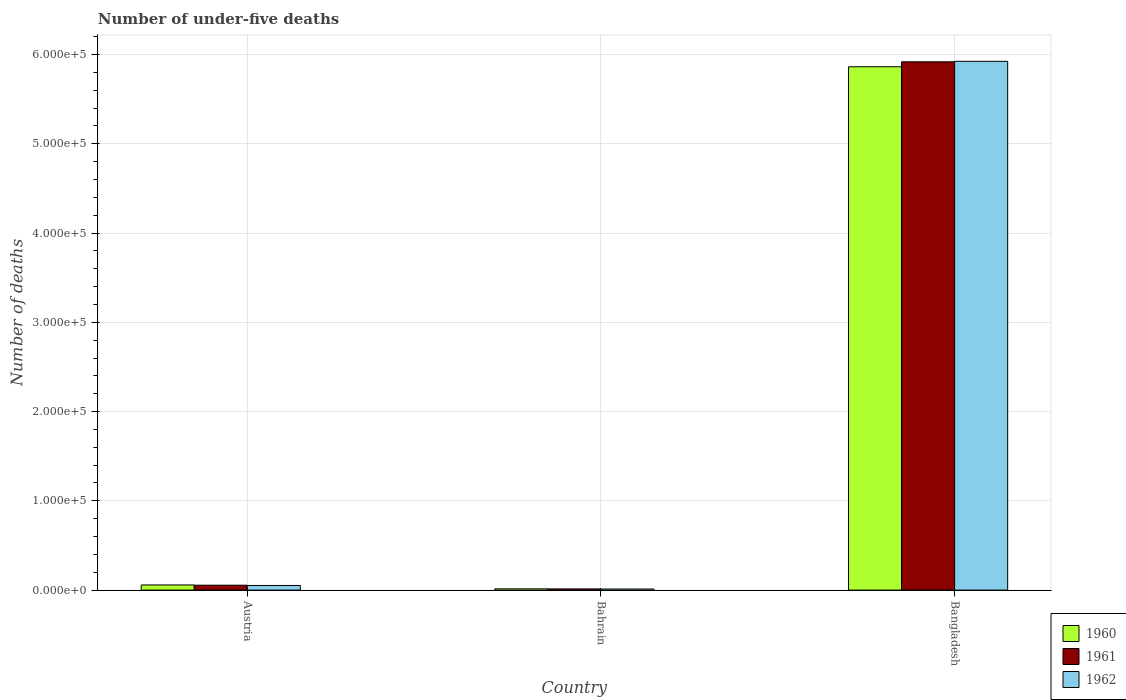How many different coloured bars are there?
Ensure brevity in your answer.  3. Are the number of bars per tick equal to the number of legend labels?
Keep it short and to the point. Yes. Are the number of bars on each tick of the X-axis equal?
Ensure brevity in your answer.  Yes. How many bars are there on the 2nd tick from the left?
Provide a succinct answer. 3. How many bars are there on the 3rd tick from the right?
Your response must be concise. 3. What is the number of under-five deaths in 1960 in Bahrain?
Provide a short and direct response. 1410. Across all countries, what is the maximum number of under-five deaths in 1961?
Provide a short and direct response. 5.92e+05. Across all countries, what is the minimum number of under-five deaths in 1962?
Make the answer very short. 1207. In which country was the number of under-five deaths in 1960 maximum?
Your answer should be very brief. Bangladesh. In which country was the number of under-five deaths in 1960 minimum?
Make the answer very short. Bahrain. What is the total number of under-five deaths in 1962 in the graph?
Make the answer very short. 5.99e+05. What is the difference between the number of under-five deaths in 1961 in Bahrain and that in Bangladesh?
Offer a terse response. -5.91e+05. What is the difference between the number of under-five deaths in 1960 in Bangladesh and the number of under-five deaths in 1961 in Austria?
Give a very brief answer. 5.81e+05. What is the average number of under-five deaths in 1960 per country?
Offer a very short reply. 1.98e+05. What is the difference between the number of under-five deaths of/in 1961 and number of under-five deaths of/in 1962 in Austria?
Your answer should be compact. 319. What is the ratio of the number of under-five deaths in 1961 in Austria to that in Bahrain?
Provide a short and direct response. 4.16. Is the number of under-five deaths in 1960 in Austria less than that in Bahrain?
Your response must be concise. No. Is the difference between the number of under-five deaths in 1961 in Bahrain and Bangladesh greater than the difference between the number of under-five deaths in 1962 in Bahrain and Bangladesh?
Provide a short and direct response. Yes. What is the difference between the highest and the second highest number of under-five deaths in 1962?
Your answer should be very brief. -5.91e+05. What is the difference between the highest and the lowest number of under-five deaths in 1962?
Your answer should be very brief. 5.91e+05. In how many countries, is the number of under-five deaths in 1961 greater than the average number of under-five deaths in 1961 taken over all countries?
Offer a very short reply. 1. What does the 2nd bar from the left in Bahrain represents?
Ensure brevity in your answer.  1961. Is it the case that in every country, the sum of the number of under-five deaths in 1960 and number of under-five deaths in 1962 is greater than the number of under-five deaths in 1961?
Make the answer very short. Yes. How many bars are there?
Ensure brevity in your answer.  9. What is the difference between two consecutive major ticks on the Y-axis?
Give a very brief answer. 1.00e+05. Does the graph contain grids?
Offer a very short reply. Yes. How many legend labels are there?
Your response must be concise. 3. How are the legend labels stacked?
Your answer should be compact. Vertical. What is the title of the graph?
Make the answer very short. Number of under-five deaths. What is the label or title of the X-axis?
Your answer should be compact. Country. What is the label or title of the Y-axis?
Your response must be concise. Number of deaths. What is the Number of deaths of 1960 in Austria?
Your answer should be very brief. 5754. What is the Number of deaths of 1961 in Austria?
Your answer should be compact. 5502. What is the Number of deaths of 1962 in Austria?
Provide a succinct answer. 5183. What is the Number of deaths of 1960 in Bahrain?
Your answer should be compact. 1410. What is the Number of deaths of 1961 in Bahrain?
Your response must be concise. 1323. What is the Number of deaths of 1962 in Bahrain?
Give a very brief answer. 1207. What is the Number of deaths of 1960 in Bangladesh?
Your response must be concise. 5.86e+05. What is the Number of deaths of 1961 in Bangladesh?
Your response must be concise. 5.92e+05. What is the Number of deaths of 1962 in Bangladesh?
Keep it short and to the point. 5.92e+05. Across all countries, what is the maximum Number of deaths of 1960?
Ensure brevity in your answer.  5.86e+05. Across all countries, what is the maximum Number of deaths of 1961?
Your response must be concise. 5.92e+05. Across all countries, what is the maximum Number of deaths in 1962?
Your answer should be very brief. 5.92e+05. Across all countries, what is the minimum Number of deaths of 1960?
Provide a succinct answer. 1410. Across all countries, what is the minimum Number of deaths in 1961?
Your answer should be very brief. 1323. Across all countries, what is the minimum Number of deaths of 1962?
Your answer should be compact. 1207. What is the total Number of deaths in 1960 in the graph?
Ensure brevity in your answer.  5.93e+05. What is the total Number of deaths in 1961 in the graph?
Make the answer very short. 5.99e+05. What is the total Number of deaths in 1962 in the graph?
Provide a short and direct response. 5.99e+05. What is the difference between the Number of deaths in 1960 in Austria and that in Bahrain?
Your answer should be very brief. 4344. What is the difference between the Number of deaths of 1961 in Austria and that in Bahrain?
Offer a very short reply. 4179. What is the difference between the Number of deaths of 1962 in Austria and that in Bahrain?
Give a very brief answer. 3976. What is the difference between the Number of deaths in 1960 in Austria and that in Bangladesh?
Offer a terse response. -5.81e+05. What is the difference between the Number of deaths in 1961 in Austria and that in Bangladesh?
Give a very brief answer. -5.86e+05. What is the difference between the Number of deaths of 1962 in Austria and that in Bangladesh?
Provide a short and direct response. -5.87e+05. What is the difference between the Number of deaths in 1960 in Bahrain and that in Bangladesh?
Offer a terse response. -5.85e+05. What is the difference between the Number of deaths of 1961 in Bahrain and that in Bangladesh?
Keep it short and to the point. -5.91e+05. What is the difference between the Number of deaths in 1962 in Bahrain and that in Bangladesh?
Provide a short and direct response. -5.91e+05. What is the difference between the Number of deaths of 1960 in Austria and the Number of deaths of 1961 in Bahrain?
Make the answer very short. 4431. What is the difference between the Number of deaths of 1960 in Austria and the Number of deaths of 1962 in Bahrain?
Provide a short and direct response. 4547. What is the difference between the Number of deaths in 1961 in Austria and the Number of deaths in 1962 in Bahrain?
Your answer should be very brief. 4295. What is the difference between the Number of deaths of 1960 in Austria and the Number of deaths of 1961 in Bangladesh?
Give a very brief answer. -5.86e+05. What is the difference between the Number of deaths in 1960 in Austria and the Number of deaths in 1962 in Bangladesh?
Give a very brief answer. -5.87e+05. What is the difference between the Number of deaths in 1961 in Austria and the Number of deaths in 1962 in Bangladesh?
Ensure brevity in your answer.  -5.87e+05. What is the difference between the Number of deaths of 1960 in Bahrain and the Number of deaths of 1961 in Bangladesh?
Provide a short and direct response. -5.90e+05. What is the difference between the Number of deaths in 1960 in Bahrain and the Number of deaths in 1962 in Bangladesh?
Provide a succinct answer. -5.91e+05. What is the difference between the Number of deaths in 1961 in Bahrain and the Number of deaths in 1962 in Bangladesh?
Make the answer very short. -5.91e+05. What is the average Number of deaths of 1960 per country?
Offer a very short reply. 1.98e+05. What is the average Number of deaths in 1961 per country?
Give a very brief answer. 2.00e+05. What is the average Number of deaths in 1962 per country?
Your answer should be very brief. 2.00e+05. What is the difference between the Number of deaths in 1960 and Number of deaths in 1961 in Austria?
Offer a terse response. 252. What is the difference between the Number of deaths of 1960 and Number of deaths of 1962 in Austria?
Provide a short and direct response. 571. What is the difference between the Number of deaths in 1961 and Number of deaths in 1962 in Austria?
Keep it short and to the point. 319. What is the difference between the Number of deaths in 1960 and Number of deaths in 1962 in Bahrain?
Offer a terse response. 203. What is the difference between the Number of deaths in 1961 and Number of deaths in 1962 in Bahrain?
Offer a very short reply. 116. What is the difference between the Number of deaths in 1960 and Number of deaths in 1961 in Bangladesh?
Provide a short and direct response. -5561. What is the difference between the Number of deaths in 1960 and Number of deaths in 1962 in Bangladesh?
Ensure brevity in your answer.  -6106. What is the difference between the Number of deaths in 1961 and Number of deaths in 1962 in Bangladesh?
Ensure brevity in your answer.  -545. What is the ratio of the Number of deaths of 1960 in Austria to that in Bahrain?
Your response must be concise. 4.08. What is the ratio of the Number of deaths in 1961 in Austria to that in Bahrain?
Provide a short and direct response. 4.16. What is the ratio of the Number of deaths in 1962 in Austria to that in Bahrain?
Your answer should be compact. 4.29. What is the ratio of the Number of deaths in 1960 in Austria to that in Bangladesh?
Provide a short and direct response. 0.01. What is the ratio of the Number of deaths in 1961 in Austria to that in Bangladesh?
Your answer should be compact. 0.01. What is the ratio of the Number of deaths of 1962 in Austria to that in Bangladesh?
Offer a terse response. 0.01. What is the ratio of the Number of deaths of 1960 in Bahrain to that in Bangladesh?
Provide a short and direct response. 0. What is the ratio of the Number of deaths of 1961 in Bahrain to that in Bangladesh?
Offer a very short reply. 0. What is the ratio of the Number of deaths in 1962 in Bahrain to that in Bangladesh?
Your answer should be very brief. 0. What is the difference between the highest and the second highest Number of deaths in 1960?
Offer a terse response. 5.81e+05. What is the difference between the highest and the second highest Number of deaths of 1961?
Ensure brevity in your answer.  5.86e+05. What is the difference between the highest and the second highest Number of deaths of 1962?
Offer a terse response. 5.87e+05. What is the difference between the highest and the lowest Number of deaths of 1960?
Offer a terse response. 5.85e+05. What is the difference between the highest and the lowest Number of deaths in 1961?
Provide a succinct answer. 5.91e+05. What is the difference between the highest and the lowest Number of deaths of 1962?
Ensure brevity in your answer.  5.91e+05. 